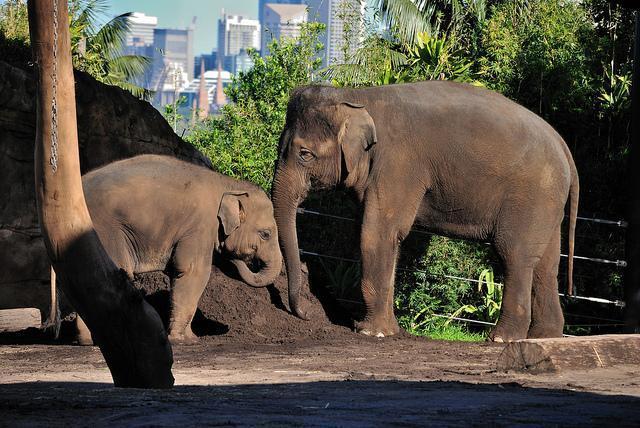How many elephants are in the scene?
Give a very brief answer. 2. How many elephants are there?
Give a very brief answer. 2. How many elephants are visible?
Give a very brief answer. 2. How many trucks are in the photo?
Give a very brief answer. 0. 